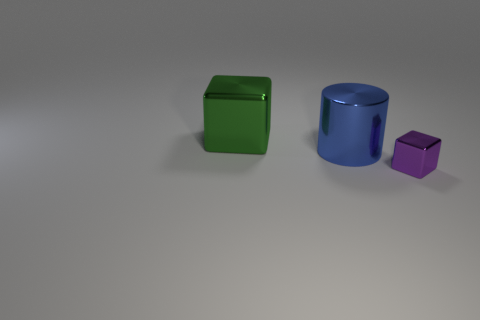There is a block that is behind the shiny block right of the large blue shiny object; are there any blue objects that are left of it?
Provide a short and direct response. No. What number of rubber objects are cubes or green objects?
Your response must be concise. 0. What number of other objects are there of the same shape as the tiny purple object?
Make the answer very short. 1. Is the number of small blue cylinders greater than the number of big blue cylinders?
Your response must be concise. No. There is a metallic cube that is to the left of the shiny block that is in front of the metal cube behind the small metal object; how big is it?
Provide a short and direct response. Large. What size is the block to the right of the large green metal object?
Your answer should be very brief. Small. How many objects are small purple objects or cubes that are in front of the large blue thing?
Your answer should be compact. 1. What number of other objects are the same size as the blue object?
Make the answer very short. 1. There is another object that is the same shape as the purple thing; what is its material?
Ensure brevity in your answer.  Metal. Is the number of blocks behind the big blue cylinder greater than the number of large green shiny things?
Your answer should be very brief. No. 